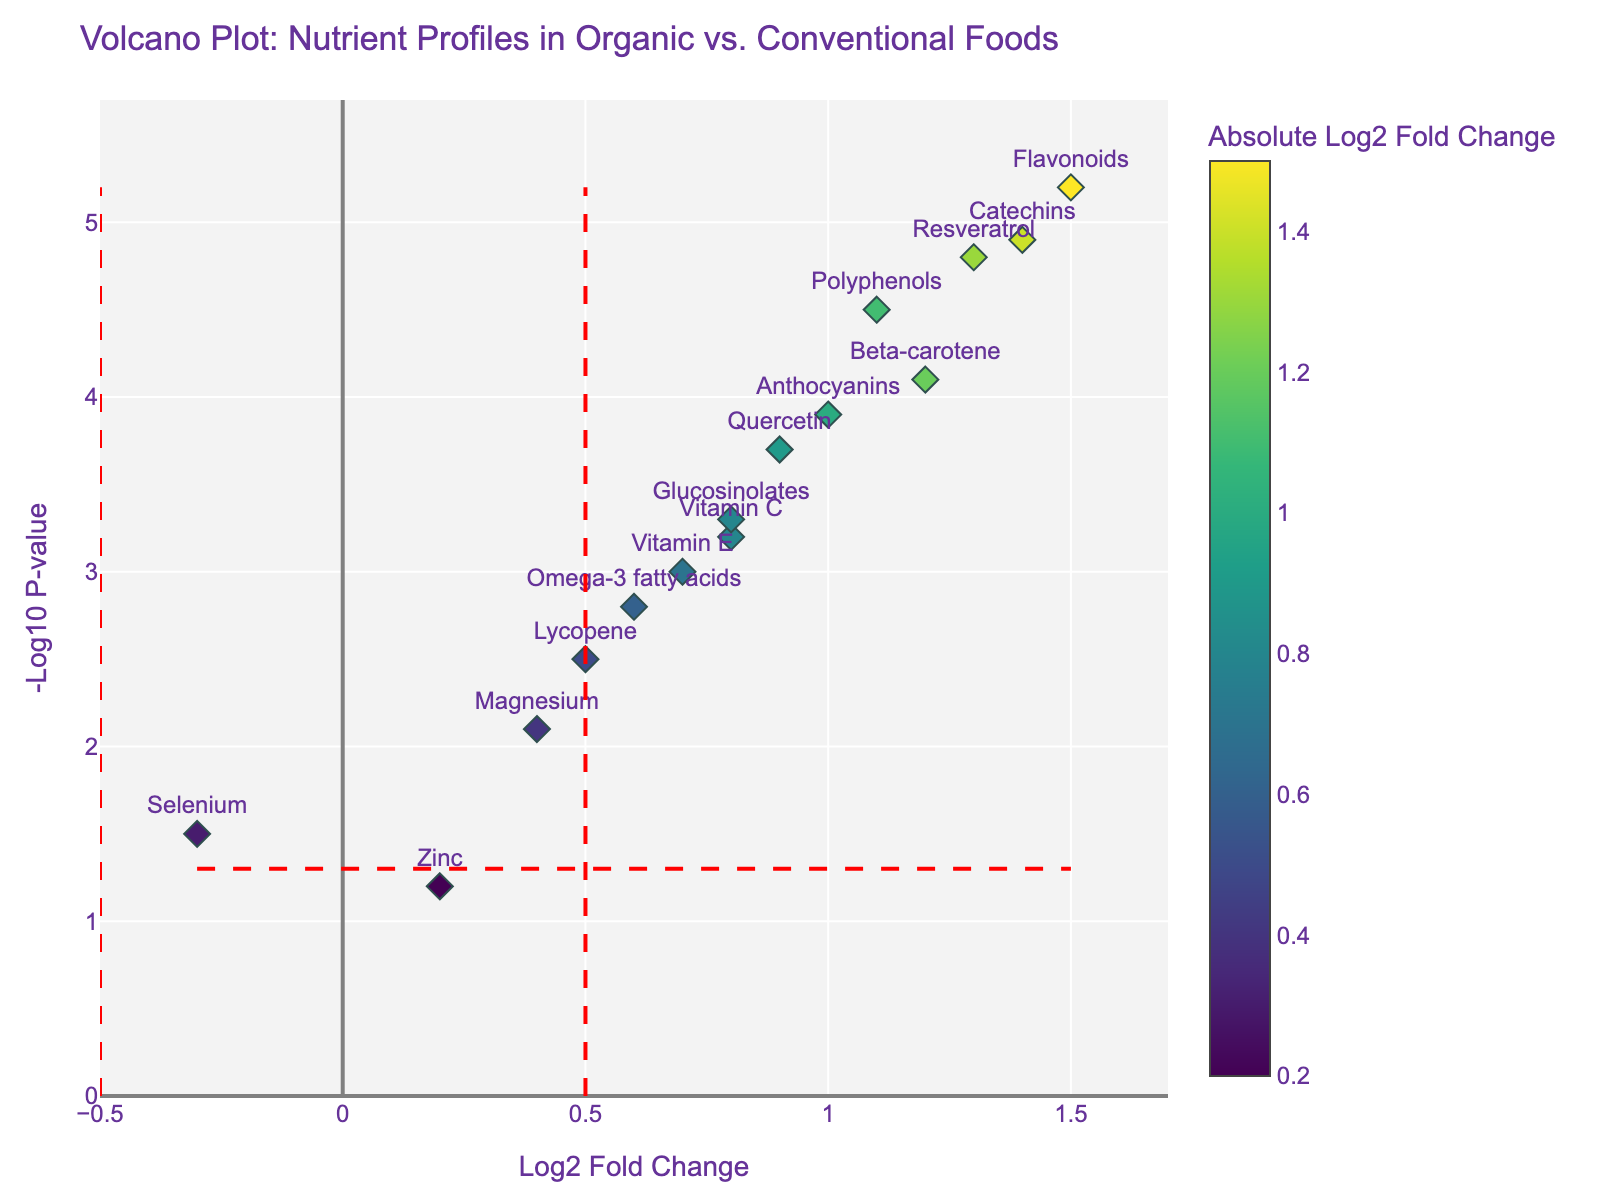How many nutrients are labeled on the plot? The plot includes markers for each nutrient, and each marker is labeled with the nutrient's name. By counting the number of unique labels, we find there are 15 labeled nutrients.
Answer: 15 What is the title of the plot? The title is usually displayed prominently at the top of the plot. In this case, it reads "Volcano Plot: Nutrient Profiles in Organic vs. Conventional Foods."
Answer: Volcano Plot: Nutrient Profiles in Organic vs. Conventional Foods Which nutrient has the highest log2 fold change? By looking at the x-axis (Log2 Fold Change), the nutrient with the highest value is positioned the farthest to the right. Flavonoids have the highest log2 fold change with a value of 1.5.
Answer: Flavonoids Which nutrient has the lowest negative log10 p-value? The y-axis represents the negative log10 p-value, with lower values towards the bottom. Zinc has the lowest negative log10 p-value at 1.2.
Answer: Zinc How many nutrients show a log2 fold change greater than 1? To answer this, count the nutrients with their markers positioned to the right of the vertical line at log2 fold change = 1. Beta-carotene, Flavonoids, Resveratrol, and Catechins qualify.
Answer: 4 Which nutrients have a log2 fold change less than 0? The nutrients with markers left of the vertical line at log2 fold change = 0 are identified. Selenium is the only nutrient meeting this criterion.
Answer: Selenium What is the log2 fold change and negative log10 p-value of Quercetin? Locate Quercetin on the plot and read its values on the x-axis and y-axis. Its log2 fold change is 0.9, and its negative log10 p-value is 3.7.
Answer: Log2 Fold Change: 0.9, -log10(p-value): 3.7 Which nutrient has a log2 fold change closest to 1? Identify the nutrients with log2 fold change nearest to 1 by comparing the numerical values. Polyphenols and Anthocyanins both have a log2 fold change of 1.0.
Answer: Polyphenols and Anthocyanins What color represents the highest log2 fold change on the color bar? The color bar's scale is inspected to determine the color associated with the highest log2 fold change. The highest values are represented by the yellowish color in the Viridis color scheme.
Answer: Yellowish What do the red dashed lines represent on the plot? The plot displays red dashed lines which are typically threshold indicators. Along the y-axis, it signifies p = 0.05, and along the x-axis, they represent the log2 fold change threshold of ±0.5.
Answer: Threshold lines for p-value = 0.05 and log2 fold change = ±0.5 